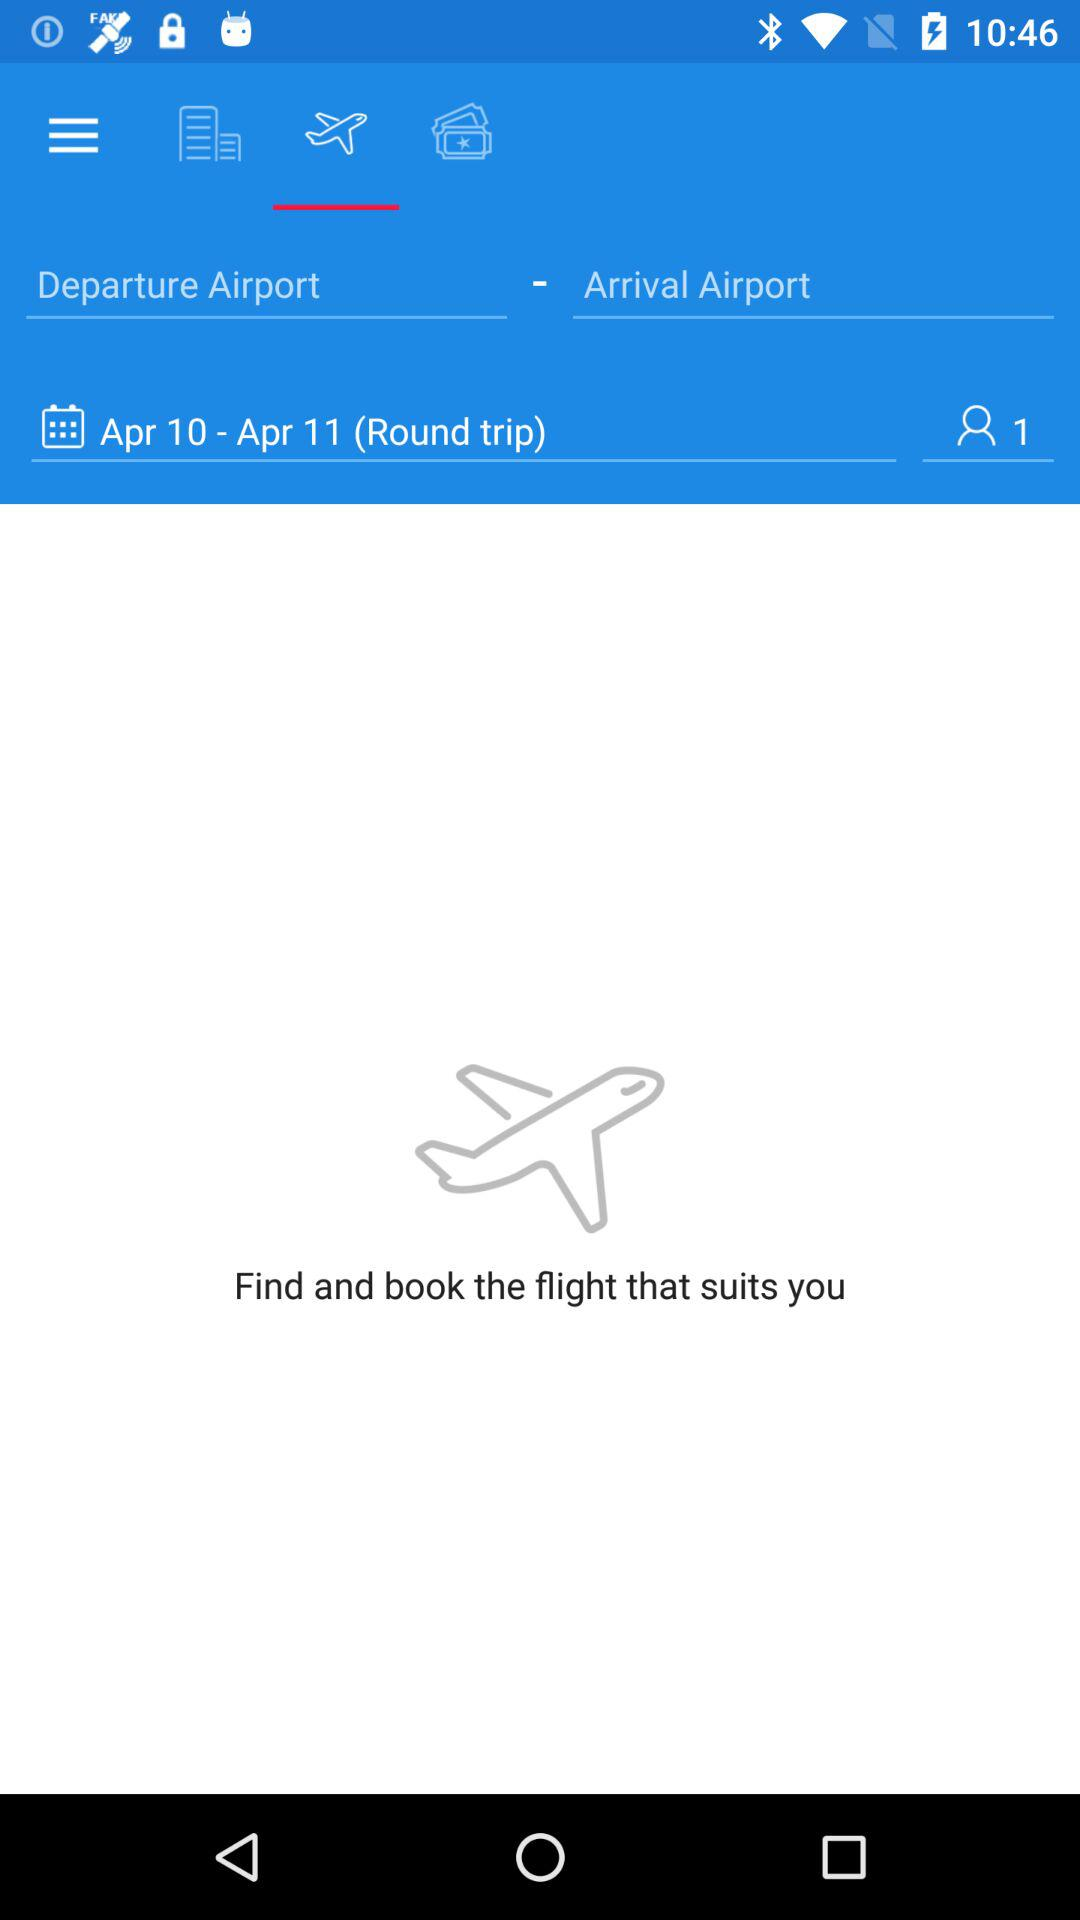How many people are traveling?
Answer the question using a single word or phrase. 1 